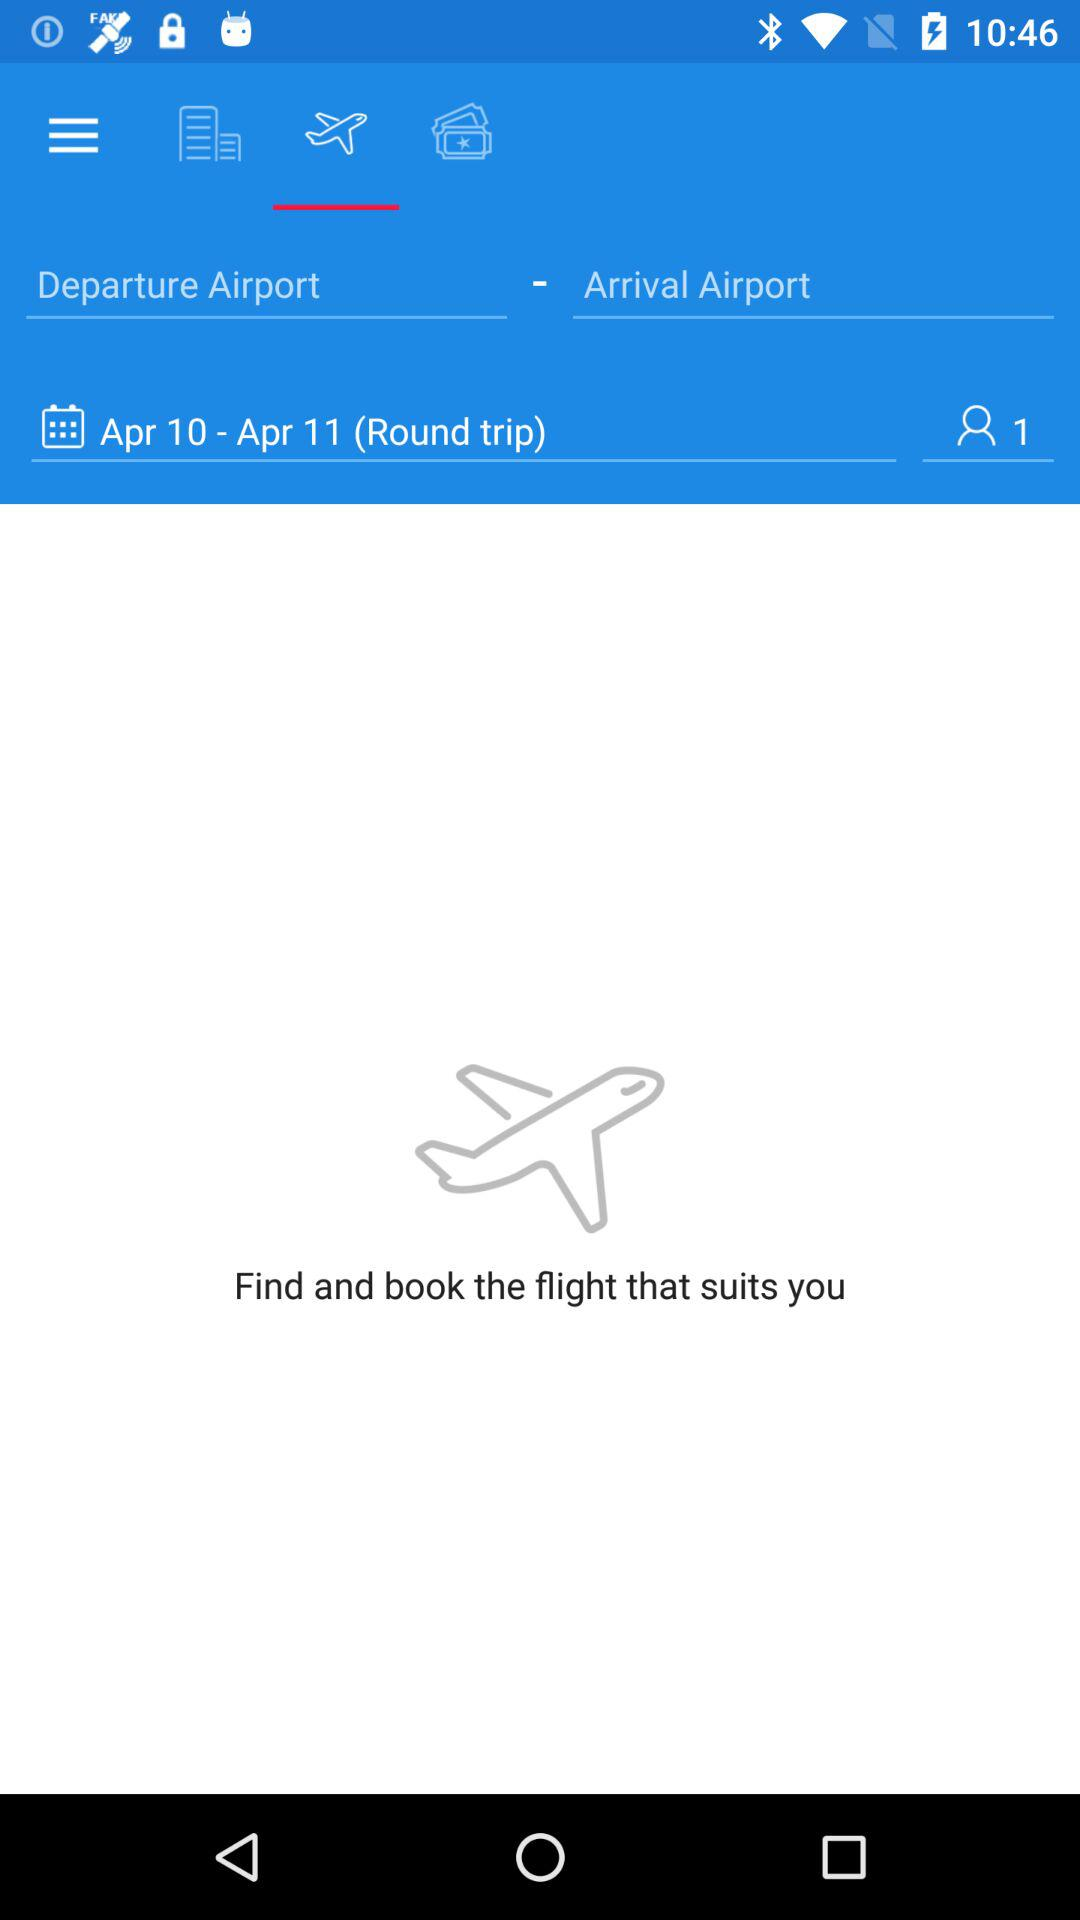How many people are traveling?
Answer the question using a single word or phrase. 1 